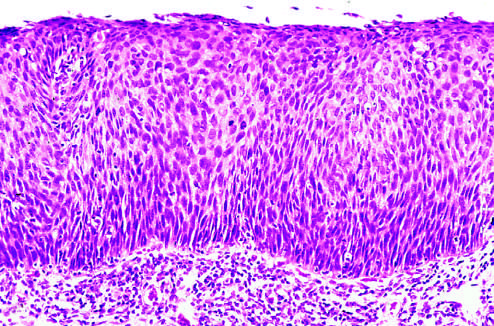s there no tumor in the subepithelial stroma?
Answer the question using a single word or phrase. Yes 